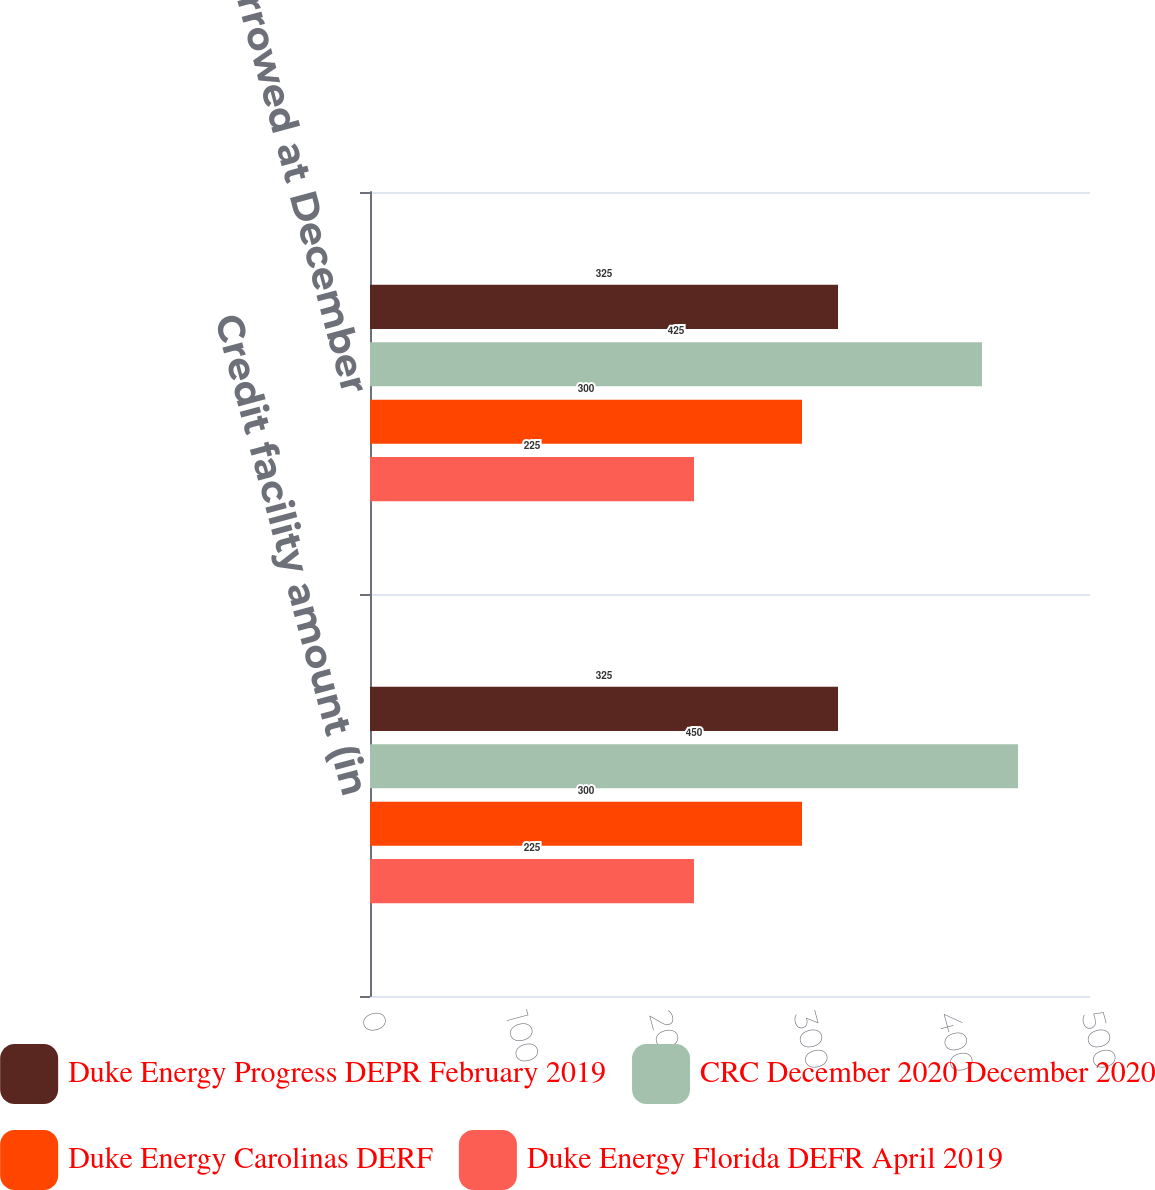<chart> <loc_0><loc_0><loc_500><loc_500><stacked_bar_chart><ecel><fcel>Credit facility amount (in<fcel>Amounts borrowed at December<nl><fcel>Duke Energy Progress DEPR February 2019<fcel>325<fcel>325<nl><fcel>CRC December 2020 December 2020<fcel>450<fcel>425<nl><fcel>Duke Energy Carolinas DERF<fcel>300<fcel>300<nl><fcel>Duke Energy Florida DEFR April 2019<fcel>225<fcel>225<nl></chart> 